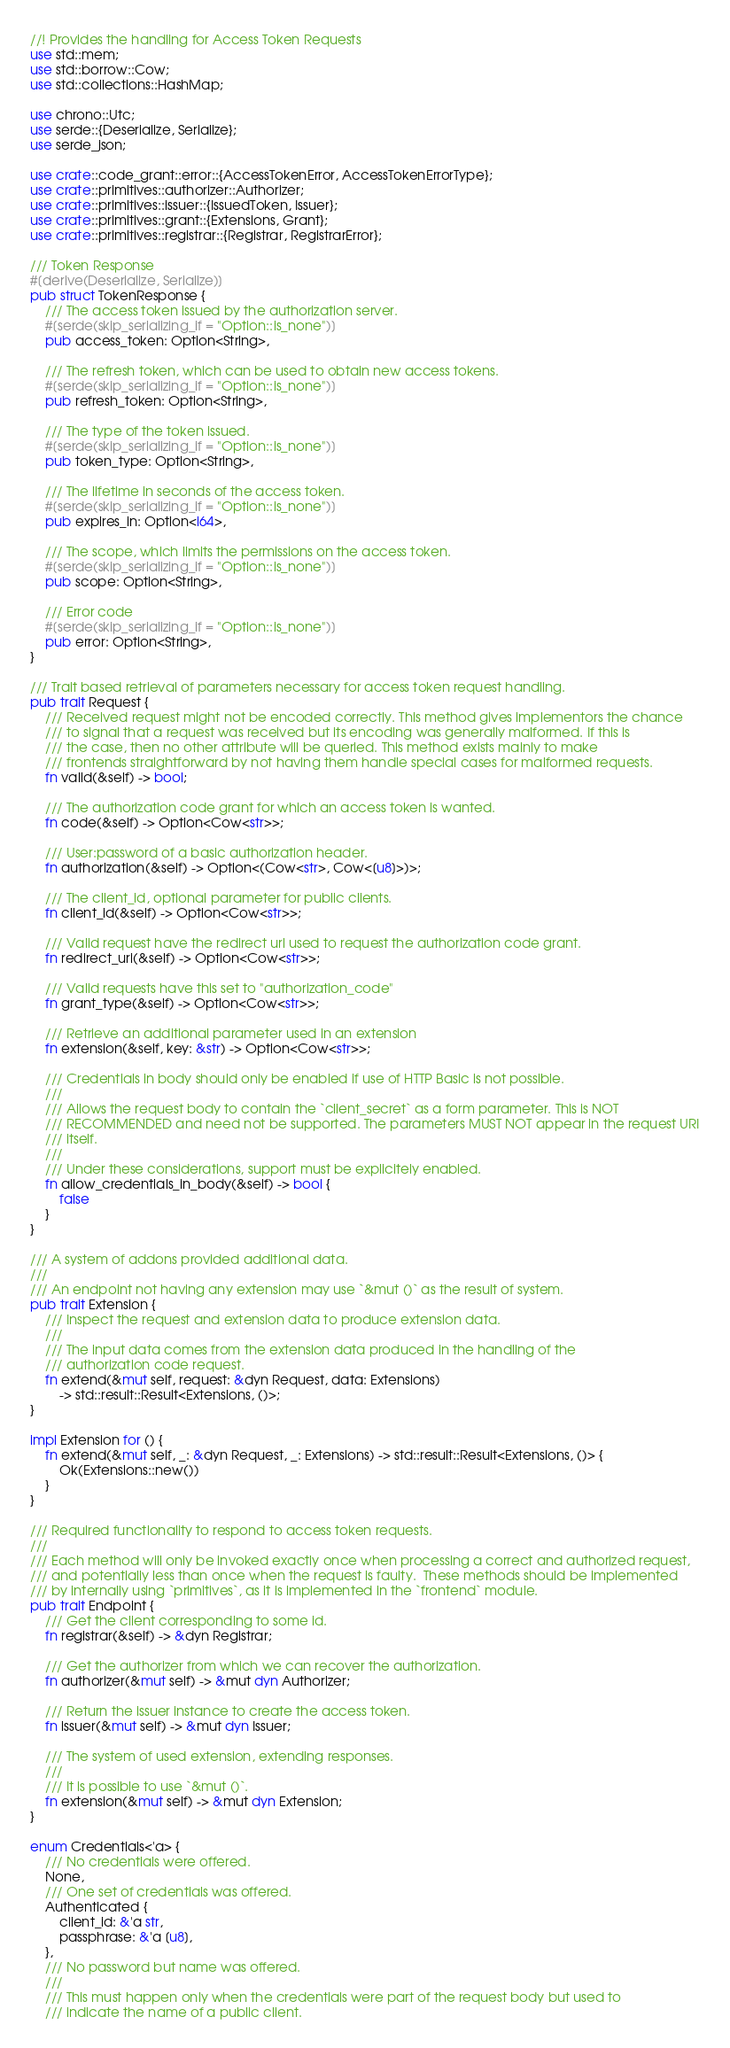Convert code to text. <code><loc_0><loc_0><loc_500><loc_500><_Rust_>//! Provides the handling for Access Token Requests
use std::mem;
use std::borrow::Cow;
use std::collections::HashMap;

use chrono::Utc;
use serde::{Deserialize, Serialize};
use serde_json;

use crate::code_grant::error::{AccessTokenError, AccessTokenErrorType};
use crate::primitives::authorizer::Authorizer;
use crate::primitives::issuer::{IssuedToken, Issuer};
use crate::primitives::grant::{Extensions, Grant};
use crate::primitives::registrar::{Registrar, RegistrarError};

/// Token Response
#[derive(Deserialize, Serialize)]
pub struct TokenResponse {
    /// The access token issued by the authorization server.
    #[serde(skip_serializing_if = "Option::is_none")]
    pub access_token: Option<String>,

    /// The refresh token, which can be used to obtain new access tokens.
    #[serde(skip_serializing_if = "Option::is_none")]
    pub refresh_token: Option<String>,

    /// The type of the token issued.
    #[serde(skip_serializing_if = "Option::is_none")]
    pub token_type: Option<String>,

    /// The lifetime in seconds of the access token.
    #[serde(skip_serializing_if = "Option::is_none")]
    pub expires_in: Option<i64>,

    /// The scope, which limits the permissions on the access token.
    #[serde(skip_serializing_if = "Option::is_none")]
    pub scope: Option<String>,

    /// Error code
    #[serde(skip_serializing_if = "Option::is_none")]
    pub error: Option<String>,
}

/// Trait based retrieval of parameters necessary for access token request handling.
pub trait Request {
    /// Received request might not be encoded correctly. This method gives implementors the chance
    /// to signal that a request was received but its encoding was generally malformed. If this is
    /// the case, then no other attribute will be queried. This method exists mainly to make
    /// frontends straightforward by not having them handle special cases for malformed requests.
    fn valid(&self) -> bool;

    /// The authorization code grant for which an access token is wanted.
    fn code(&self) -> Option<Cow<str>>;

    /// User:password of a basic authorization header.
    fn authorization(&self) -> Option<(Cow<str>, Cow<[u8]>)>;

    /// The client_id, optional parameter for public clients.
    fn client_id(&self) -> Option<Cow<str>>;

    /// Valid request have the redirect url used to request the authorization code grant.
    fn redirect_uri(&self) -> Option<Cow<str>>;

    /// Valid requests have this set to "authorization_code"
    fn grant_type(&self) -> Option<Cow<str>>;

    /// Retrieve an additional parameter used in an extension
    fn extension(&self, key: &str) -> Option<Cow<str>>;

    /// Credentials in body should only be enabled if use of HTTP Basic is not possible.
    ///
    /// Allows the request body to contain the `client_secret` as a form parameter. This is NOT
    /// RECOMMENDED and need not be supported. The parameters MUST NOT appear in the request URI
    /// itself.
    ///
    /// Under these considerations, support must be explicitely enabled.
    fn allow_credentials_in_body(&self) -> bool {
        false
    }
}

/// A system of addons provided additional data.
///
/// An endpoint not having any extension may use `&mut ()` as the result of system.
pub trait Extension {
    /// Inspect the request and extension data to produce extension data.
    ///
    /// The input data comes from the extension data produced in the handling of the
    /// authorization code request.
    fn extend(&mut self, request: &dyn Request, data: Extensions)
        -> std::result::Result<Extensions, ()>;
}

impl Extension for () {
    fn extend(&mut self, _: &dyn Request, _: Extensions) -> std::result::Result<Extensions, ()> {
        Ok(Extensions::new())
    }
}

/// Required functionality to respond to access token requests.
///
/// Each method will only be invoked exactly once when processing a correct and authorized request,
/// and potentially less than once when the request is faulty.  These methods should be implemented
/// by internally using `primitives`, as it is implemented in the `frontend` module.
pub trait Endpoint {
    /// Get the client corresponding to some id.
    fn registrar(&self) -> &dyn Registrar;

    /// Get the authorizer from which we can recover the authorization.
    fn authorizer(&mut self) -> &mut dyn Authorizer;

    /// Return the issuer instance to create the access token.
    fn issuer(&mut self) -> &mut dyn Issuer;

    /// The system of used extension, extending responses.
    ///
    /// It is possible to use `&mut ()`.
    fn extension(&mut self) -> &mut dyn Extension;
}

enum Credentials<'a> {
    /// No credentials were offered.
    None,
    /// One set of credentials was offered.
    Authenticated {
        client_id: &'a str,
        passphrase: &'a [u8],
    },
    /// No password but name was offered.
    ///
    /// This must happen only when the credentials were part of the request body but used to
    /// indicate the name of a public client.</code> 